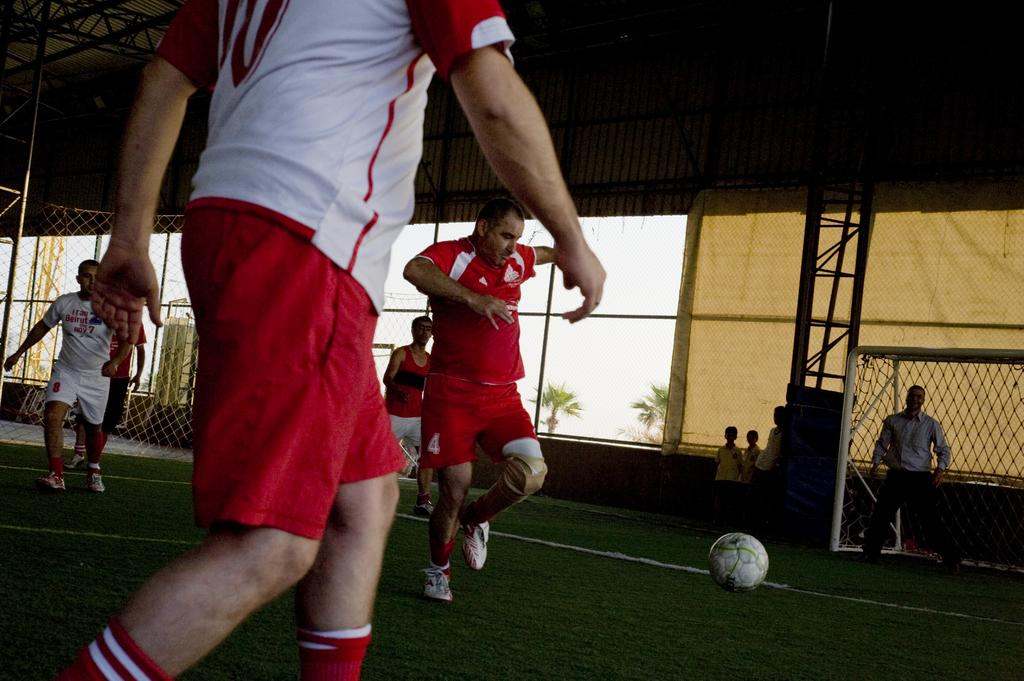What activity are the persons in the image engaged in? The persons in the image are playing football. What is the main object used in the game? There is a football in the image. What is used to indicate the goal in the game? There is a football net in the image. What can be seen in the background of the image? There are two trees in the background of the image. What type of barrier is visible in the image? There is fencing visible in the image. Can you see any sponge rings on the coast in the image? There is no coast or sponge rings present in the image; it features a football game with a football net, trees, and fencing. 